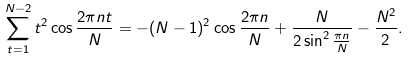Convert formula to latex. <formula><loc_0><loc_0><loc_500><loc_500>\sum ^ { N - 2 } _ { t = 1 } t ^ { 2 } \cos \frac { 2 \pi n t } { N } = - ( N - 1 ) ^ { 2 } \cos \frac { 2 \pi n } { N } + \frac { N } { 2 \sin ^ { 2 } \frac { \pi n } { N } } - \frac { N ^ { 2 } } { 2 } .</formula> 